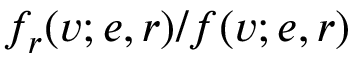Convert formula to latex. <formula><loc_0><loc_0><loc_500><loc_500>f _ { r } ( v ; e , r ) / f ( v ; e , r )</formula> 